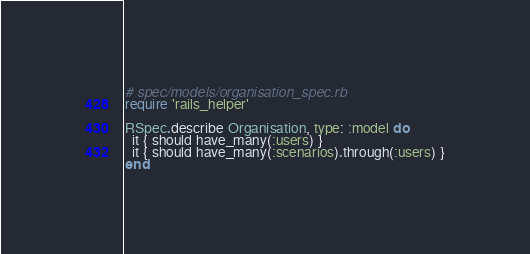<code> <loc_0><loc_0><loc_500><loc_500><_Ruby_># spec/models/organisation_spec.rb
require 'rails_helper'

RSpec.describe Organisation, type: :model do
  it { should have_many(:users) }
  it { should have_many(:scenarios).through(:users) }
end
</code> 